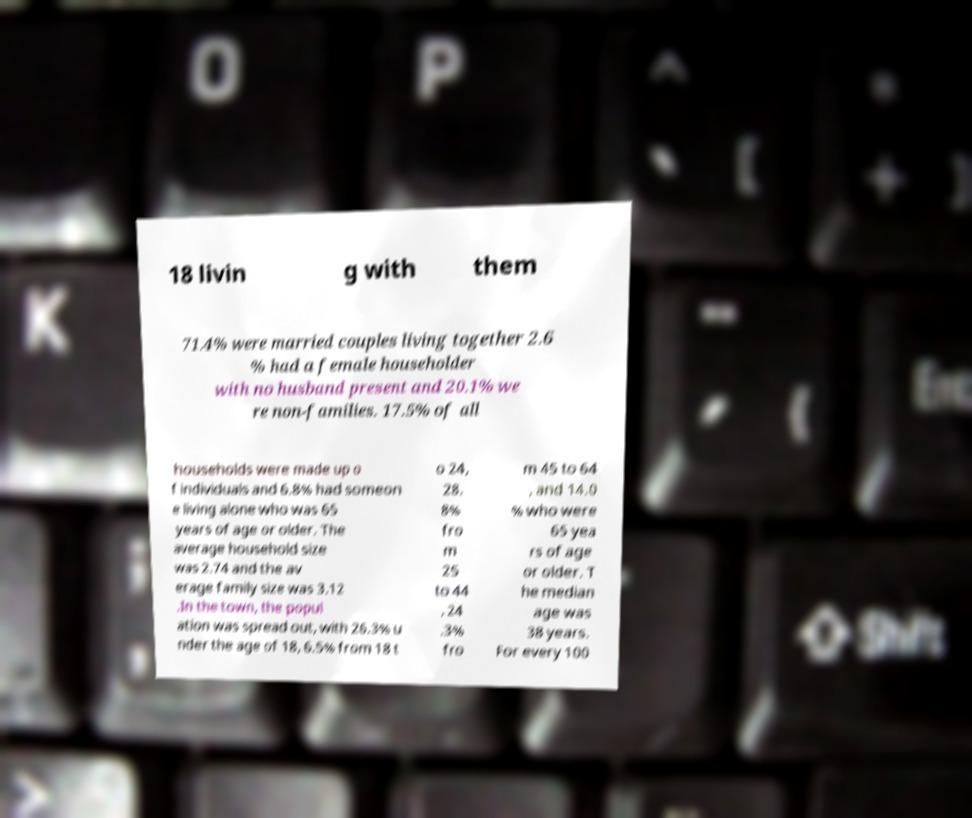Could you extract and type out the text from this image? 18 livin g with them 71.4% were married couples living together 2.6 % had a female householder with no husband present and 20.1% we re non-families. 17.5% of all households were made up o f individuals and 6.8% had someon e living alone who was 65 years of age or older. The average household size was 2.74 and the av erage family size was 3.12 .In the town, the popul ation was spread out, with 26.3% u nder the age of 18, 6.5% from 18 t o 24, 28. 8% fro m 25 to 44 , 24 .3% fro m 45 to 64 , and 14.0 % who were 65 yea rs of age or older. T he median age was 38 years. For every 100 